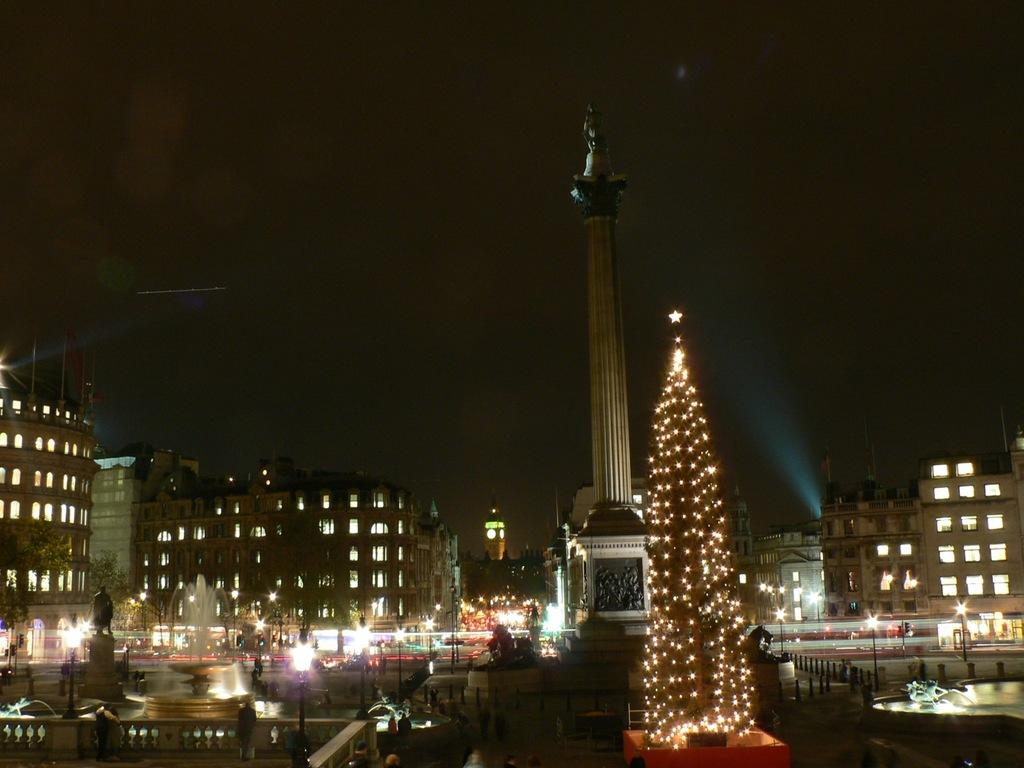What type of structures can be seen in the image? There are buildings in the image. What else can be seen in the image besides buildings? There are poles, lights, sculptures, and an xmas tree visible in the image. What is visible in the background of the image? There is sky and a tower visible in the background of the image. Can you tell me how many clouds are depicted in the image? There are no clouds depicted in the image; only the sky is visible in the background. What type of hand can be seen interacting with the sculptures in the image? There are no hands present in the image; only the sculptures themselves are visible. 